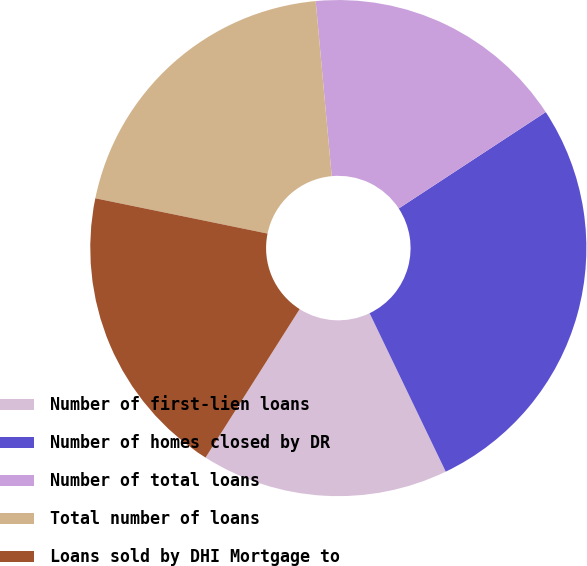<chart> <loc_0><loc_0><loc_500><loc_500><pie_chart><fcel>Number of first-lien loans<fcel>Number of homes closed by DR<fcel>Number of total loans<fcel>Total number of loans<fcel>Loans sold by DHI Mortgage to<nl><fcel>16.12%<fcel>27.11%<fcel>17.22%<fcel>20.33%<fcel>19.23%<nl></chart> 